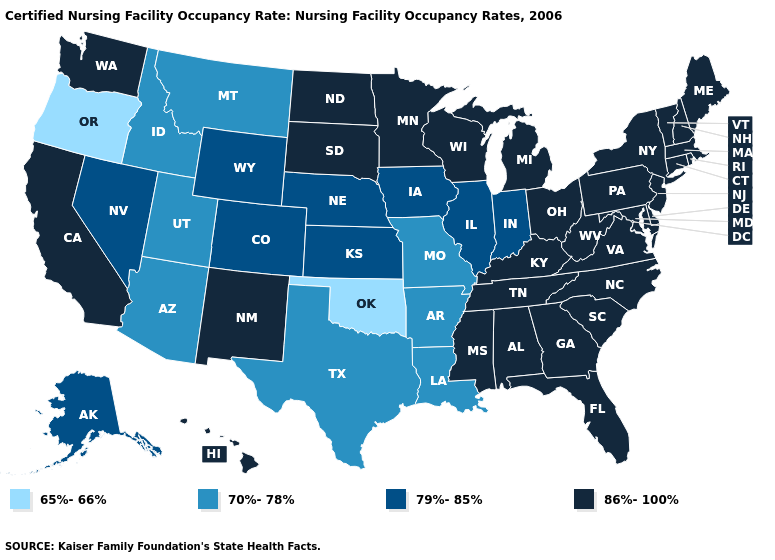What is the value of Kentucky?
Concise answer only. 86%-100%. Name the states that have a value in the range 79%-85%?
Answer briefly. Alaska, Colorado, Illinois, Indiana, Iowa, Kansas, Nebraska, Nevada, Wyoming. Name the states that have a value in the range 79%-85%?
Write a very short answer. Alaska, Colorado, Illinois, Indiana, Iowa, Kansas, Nebraska, Nevada, Wyoming. Name the states that have a value in the range 79%-85%?
Be succinct. Alaska, Colorado, Illinois, Indiana, Iowa, Kansas, Nebraska, Nevada, Wyoming. Name the states that have a value in the range 65%-66%?
Write a very short answer. Oklahoma, Oregon. Does Oregon have the lowest value in the West?
Short answer required. Yes. Which states have the highest value in the USA?
Answer briefly. Alabama, California, Connecticut, Delaware, Florida, Georgia, Hawaii, Kentucky, Maine, Maryland, Massachusetts, Michigan, Minnesota, Mississippi, New Hampshire, New Jersey, New Mexico, New York, North Carolina, North Dakota, Ohio, Pennsylvania, Rhode Island, South Carolina, South Dakota, Tennessee, Vermont, Virginia, Washington, West Virginia, Wisconsin. What is the highest value in states that border Tennessee?
Be succinct. 86%-100%. Among the states that border New Jersey , which have the highest value?
Be succinct. Delaware, New York, Pennsylvania. What is the lowest value in the West?
Concise answer only. 65%-66%. What is the value of Delaware?
Short answer required. 86%-100%. What is the highest value in states that border Illinois?
Write a very short answer. 86%-100%. Name the states that have a value in the range 86%-100%?
Quick response, please. Alabama, California, Connecticut, Delaware, Florida, Georgia, Hawaii, Kentucky, Maine, Maryland, Massachusetts, Michigan, Minnesota, Mississippi, New Hampshire, New Jersey, New Mexico, New York, North Carolina, North Dakota, Ohio, Pennsylvania, Rhode Island, South Carolina, South Dakota, Tennessee, Vermont, Virginia, Washington, West Virginia, Wisconsin. What is the value of Utah?
Short answer required. 70%-78%. 